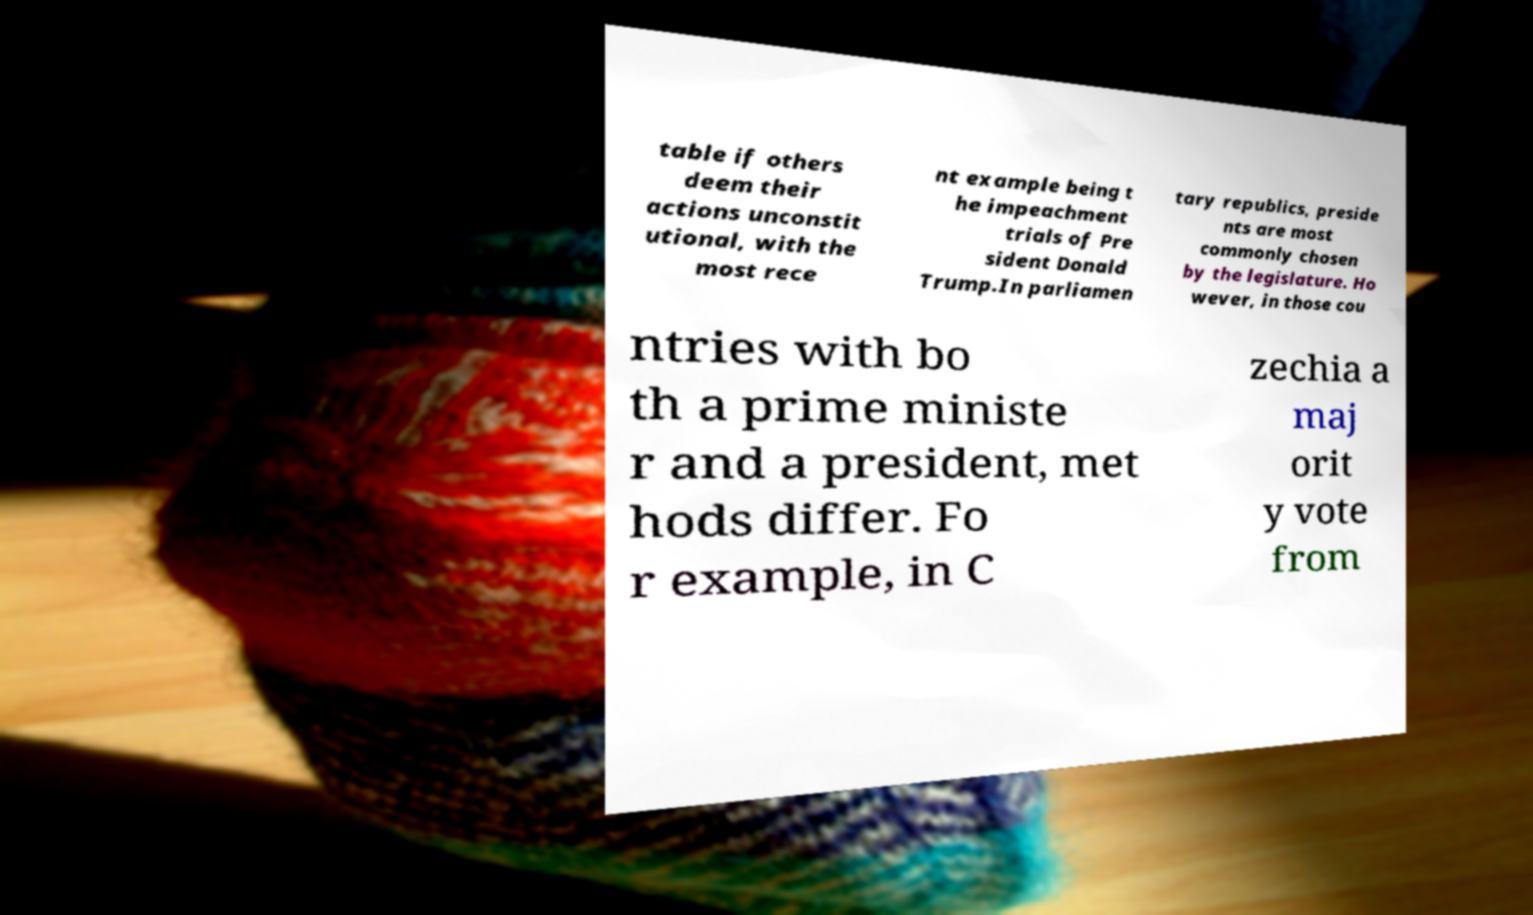Please read and relay the text visible in this image. What does it say? table if others deem their actions unconstit utional, with the most rece nt example being t he impeachment trials of Pre sident Donald Trump.In parliamen tary republics, preside nts are most commonly chosen by the legislature. Ho wever, in those cou ntries with bo th a prime ministe r and a president, met hods differ. Fo r example, in C zechia a maj orit y vote from 